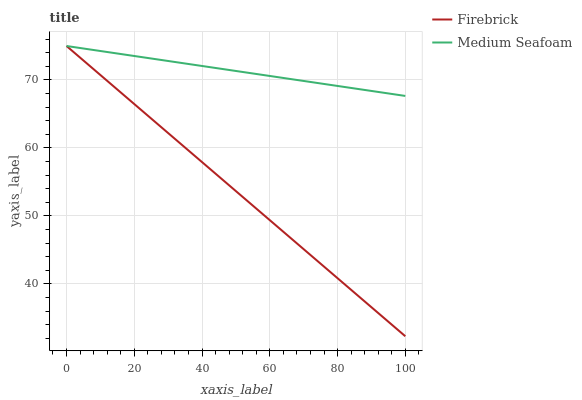Does Firebrick have the minimum area under the curve?
Answer yes or no. Yes. Does Medium Seafoam have the maximum area under the curve?
Answer yes or no. Yes. Does Medium Seafoam have the minimum area under the curve?
Answer yes or no. No. Is Firebrick the smoothest?
Answer yes or no. Yes. Is Medium Seafoam the roughest?
Answer yes or no. Yes. Is Medium Seafoam the smoothest?
Answer yes or no. No. Does Firebrick have the lowest value?
Answer yes or no. Yes. Does Medium Seafoam have the lowest value?
Answer yes or no. No. Does Medium Seafoam have the highest value?
Answer yes or no. Yes. Does Medium Seafoam intersect Firebrick?
Answer yes or no. Yes. Is Medium Seafoam less than Firebrick?
Answer yes or no. No. Is Medium Seafoam greater than Firebrick?
Answer yes or no. No. 